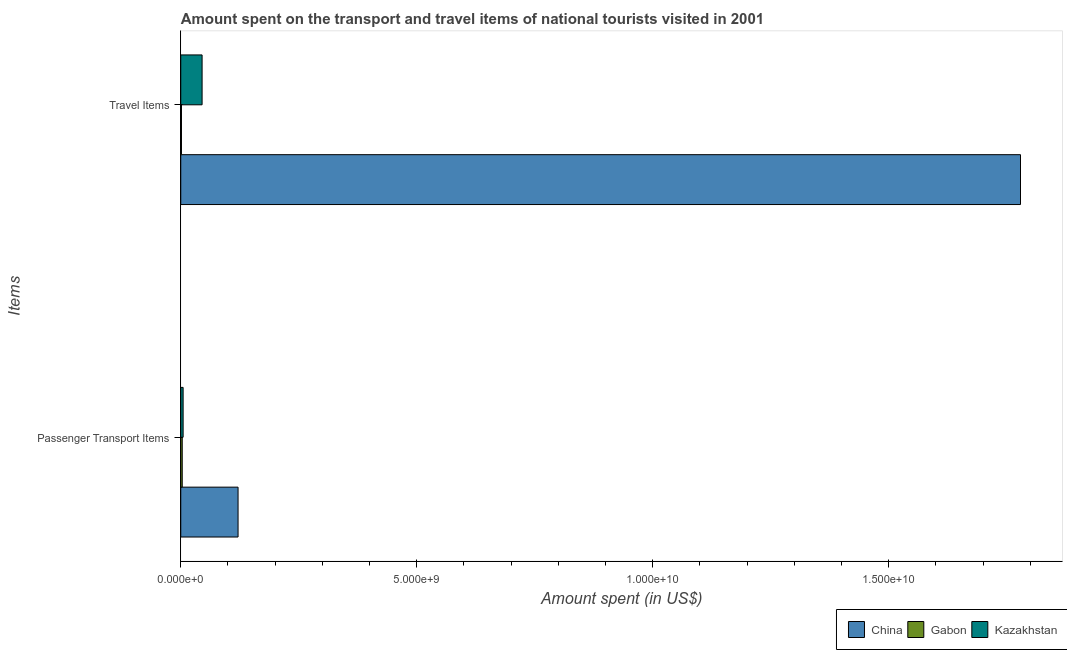Are the number of bars on each tick of the Y-axis equal?
Your answer should be compact. Yes. How many bars are there on the 1st tick from the top?
Your answer should be very brief. 3. How many bars are there on the 1st tick from the bottom?
Make the answer very short. 3. What is the label of the 1st group of bars from the top?
Provide a succinct answer. Travel Items. What is the amount spent in travel items in Kazakhstan?
Your answer should be compact. 4.52e+08. Across all countries, what is the maximum amount spent on passenger transport items?
Ensure brevity in your answer.  1.21e+09. Across all countries, what is the minimum amount spent on passenger transport items?
Give a very brief answer. 3.10e+07. In which country was the amount spent on passenger transport items minimum?
Give a very brief answer. Gabon. What is the total amount spent on passenger transport items in the graph?
Keep it short and to the point. 1.30e+09. What is the difference between the amount spent on passenger transport items in China and that in Kazakhstan?
Your answer should be compact. 1.16e+09. What is the difference between the amount spent in travel items in Gabon and the amount spent on passenger transport items in Kazakhstan?
Your response must be concise. -3.50e+07. What is the average amount spent in travel items per country?
Your answer should be compact. 6.09e+09. What is the difference between the amount spent in travel items and amount spent on passenger transport items in China?
Offer a terse response. 1.66e+1. What is the ratio of the amount spent in travel items in Kazakhstan to that in Gabon?
Provide a short and direct response. 30.13. What does the 2nd bar from the top in Passenger Transport Items represents?
Offer a very short reply. Gabon. What does the 2nd bar from the bottom in Travel Items represents?
Offer a very short reply. Gabon. Are all the bars in the graph horizontal?
Your answer should be very brief. Yes. How many countries are there in the graph?
Your response must be concise. 3. Does the graph contain any zero values?
Offer a very short reply. No. Does the graph contain grids?
Your answer should be very brief. No. What is the title of the graph?
Your answer should be compact. Amount spent on the transport and travel items of national tourists visited in 2001. What is the label or title of the X-axis?
Your answer should be very brief. Amount spent (in US$). What is the label or title of the Y-axis?
Your response must be concise. Items. What is the Amount spent (in US$) in China in Passenger Transport Items?
Keep it short and to the point. 1.21e+09. What is the Amount spent (in US$) in Gabon in Passenger Transport Items?
Offer a very short reply. 3.10e+07. What is the Amount spent (in US$) in Kazakhstan in Passenger Transport Items?
Provide a short and direct response. 5.00e+07. What is the Amount spent (in US$) of China in Travel Items?
Offer a very short reply. 1.78e+1. What is the Amount spent (in US$) of Gabon in Travel Items?
Your answer should be very brief. 1.50e+07. What is the Amount spent (in US$) of Kazakhstan in Travel Items?
Provide a succinct answer. 4.52e+08. Across all Items, what is the maximum Amount spent (in US$) in China?
Your response must be concise. 1.78e+1. Across all Items, what is the maximum Amount spent (in US$) in Gabon?
Your answer should be very brief. 3.10e+07. Across all Items, what is the maximum Amount spent (in US$) of Kazakhstan?
Offer a very short reply. 4.52e+08. Across all Items, what is the minimum Amount spent (in US$) in China?
Offer a terse response. 1.21e+09. Across all Items, what is the minimum Amount spent (in US$) of Gabon?
Offer a very short reply. 1.50e+07. What is the total Amount spent (in US$) in China in the graph?
Ensure brevity in your answer.  1.90e+1. What is the total Amount spent (in US$) of Gabon in the graph?
Your answer should be very brief. 4.60e+07. What is the total Amount spent (in US$) of Kazakhstan in the graph?
Your answer should be very brief. 5.02e+08. What is the difference between the Amount spent (in US$) of China in Passenger Transport Items and that in Travel Items?
Provide a short and direct response. -1.66e+1. What is the difference between the Amount spent (in US$) of Gabon in Passenger Transport Items and that in Travel Items?
Provide a succinct answer. 1.60e+07. What is the difference between the Amount spent (in US$) in Kazakhstan in Passenger Transport Items and that in Travel Items?
Ensure brevity in your answer.  -4.02e+08. What is the difference between the Amount spent (in US$) of China in Passenger Transport Items and the Amount spent (in US$) of Gabon in Travel Items?
Your response must be concise. 1.20e+09. What is the difference between the Amount spent (in US$) of China in Passenger Transport Items and the Amount spent (in US$) of Kazakhstan in Travel Items?
Ensure brevity in your answer.  7.62e+08. What is the difference between the Amount spent (in US$) in Gabon in Passenger Transport Items and the Amount spent (in US$) in Kazakhstan in Travel Items?
Your response must be concise. -4.21e+08. What is the average Amount spent (in US$) of China per Items?
Provide a succinct answer. 9.50e+09. What is the average Amount spent (in US$) in Gabon per Items?
Offer a terse response. 2.30e+07. What is the average Amount spent (in US$) in Kazakhstan per Items?
Make the answer very short. 2.51e+08. What is the difference between the Amount spent (in US$) in China and Amount spent (in US$) in Gabon in Passenger Transport Items?
Offer a very short reply. 1.18e+09. What is the difference between the Amount spent (in US$) in China and Amount spent (in US$) in Kazakhstan in Passenger Transport Items?
Offer a very short reply. 1.16e+09. What is the difference between the Amount spent (in US$) of Gabon and Amount spent (in US$) of Kazakhstan in Passenger Transport Items?
Keep it short and to the point. -1.90e+07. What is the difference between the Amount spent (in US$) in China and Amount spent (in US$) in Gabon in Travel Items?
Your response must be concise. 1.78e+1. What is the difference between the Amount spent (in US$) of China and Amount spent (in US$) of Kazakhstan in Travel Items?
Keep it short and to the point. 1.73e+1. What is the difference between the Amount spent (in US$) of Gabon and Amount spent (in US$) of Kazakhstan in Travel Items?
Provide a short and direct response. -4.37e+08. What is the ratio of the Amount spent (in US$) of China in Passenger Transport Items to that in Travel Items?
Your answer should be compact. 0.07. What is the ratio of the Amount spent (in US$) in Gabon in Passenger Transport Items to that in Travel Items?
Keep it short and to the point. 2.07. What is the ratio of the Amount spent (in US$) of Kazakhstan in Passenger Transport Items to that in Travel Items?
Your response must be concise. 0.11. What is the difference between the highest and the second highest Amount spent (in US$) in China?
Make the answer very short. 1.66e+1. What is the difference between the highest and the second highest Amount spent (in US$) in Gabon?
Your response must be concise. 1.60e+07. What is the difference between the highest and the second highest Amount spent (in US$) of Kazakhstan?
Ensure brevity in your answer.  4.02e+08. What is the difference between the highest and the lowest Amount spent (in US$) of China?
Make the answer very short. 1.66e+1. What is the difference between the highest and the lowest Amount spent (in US$) of Gabon?
Make the answer very short. 1.60e+07. What is the difference between the highest and the lowest Amount spent (in US$) of Kazakhstan?
Your answer should be compact. 4.02e+08. 